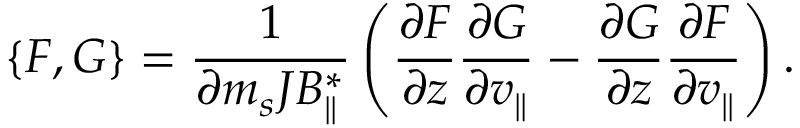Convert formula to latex. <formula><loc_0><loc_0><loc_500><loc_500>\{ F , G \} = \frac { 1 } { \partial m _ { s } J B _ { \| } ^ { * } } \left ( \frac { \partial F } { \partial z } \frac { \partial G } { \partial v _ { \| } } - \frac { \partial G } { \partial z } \frac { \partial F } { \partial v _ { \| } } \right ) .</formula> 